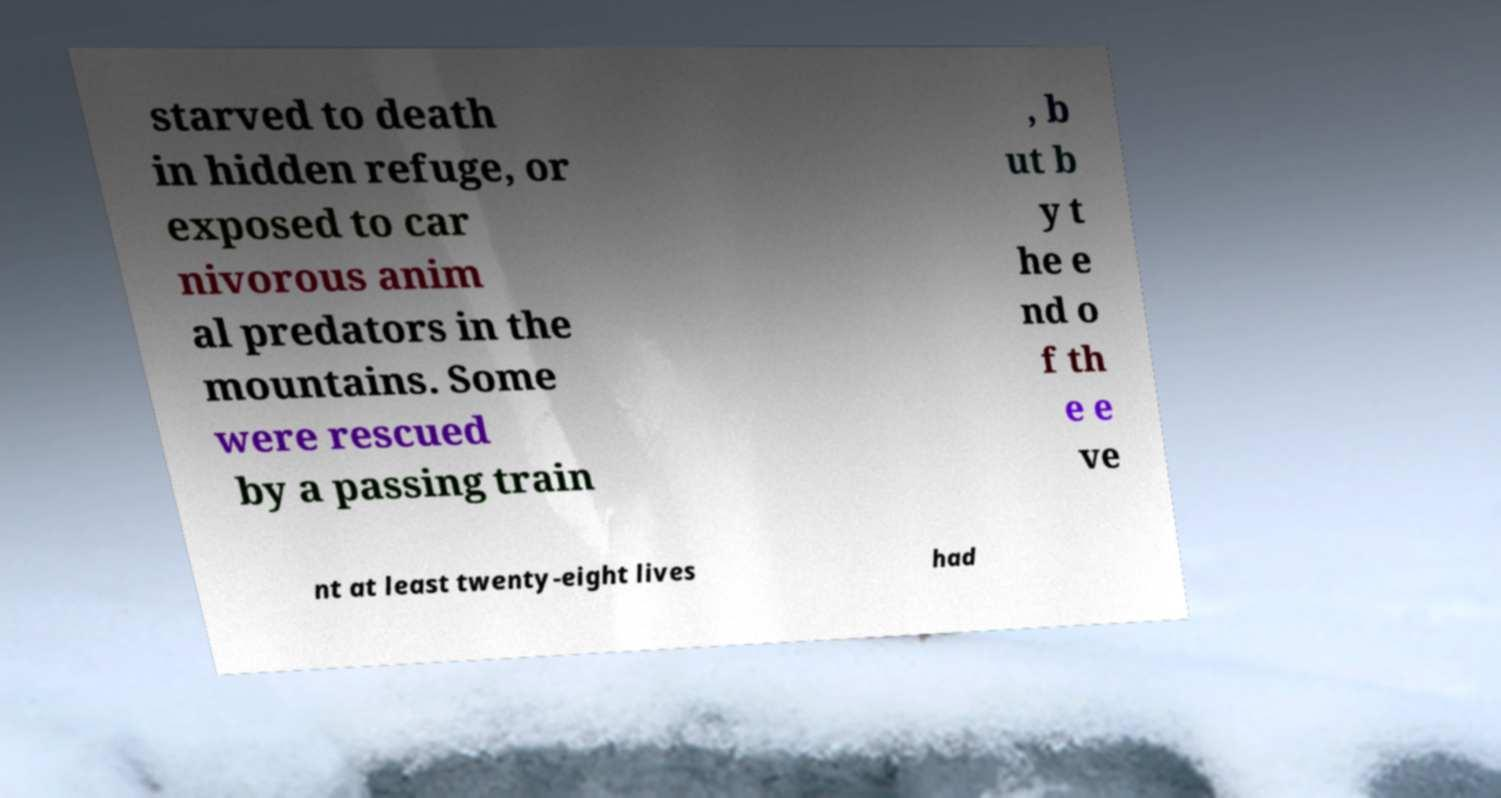There's text embedded in this image that I need extracted. Can you transcribe it verbatim? starved to death in hidden refuge, or exposed to car nivorous anim al predators in the mountains. Some were rescued by a passing train , b ut b y t he e nd o f th e e ve nt at least twenty-eight lives had 